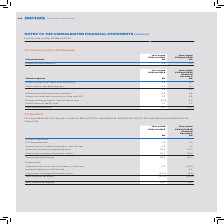According to Sophos Group's financial document, What was UK corporation tax for the year-ended 31 March 2019 calculated as? 19% (2018: 19%) of the estimated assessable loss for the period.. The document states: "for the year-ended 31 March 2019 is calculated at 19% (2018: 19%) of the estimated assessable loss for the period...." Also, What was the total income tax charge in 2019? According to the financial document, 26.7 (in millions). The relevant text states: "Total income tax charge 26.7 19.9..." Also, What are the subtotal components in the table used to calculate the total income tax charge? The document shows two values: Total current tax charge and Total deferred tax credit. From the document: "Total current tax charge 36.9 34.7 Total deferred tax credit (10.2) (14.8)..." Additionally, In which year was the total income tax charge larger? According to the financial document, 2019. The relevant text states: "For the year-ended 31 March 2019..." Also, can you calculate: What was the change in Total income tax charge in 2019 from 2018? Based on the calculation: 26.7-19.9, the result is 6.8 (in millions). This is based on the information: "Total income tax charge 26.7 19.9 Total income tax charge 26.7 19.9..." The key data points involved are: 19.9, 26.7. Also, can you calculate: What was the percentage change in Total income tax charge in 2019 from 2018? To answer this question, I need to perform calculations using the financial data. The calculation is: (26.7-19.9)/19.9, which equals 34.17 (percentage). This is based on the information: "Total income tax charge 26.7 19.9 Total income tax charge 26.7 19.9..." The key data points involved are: 19.9, 26.7. 